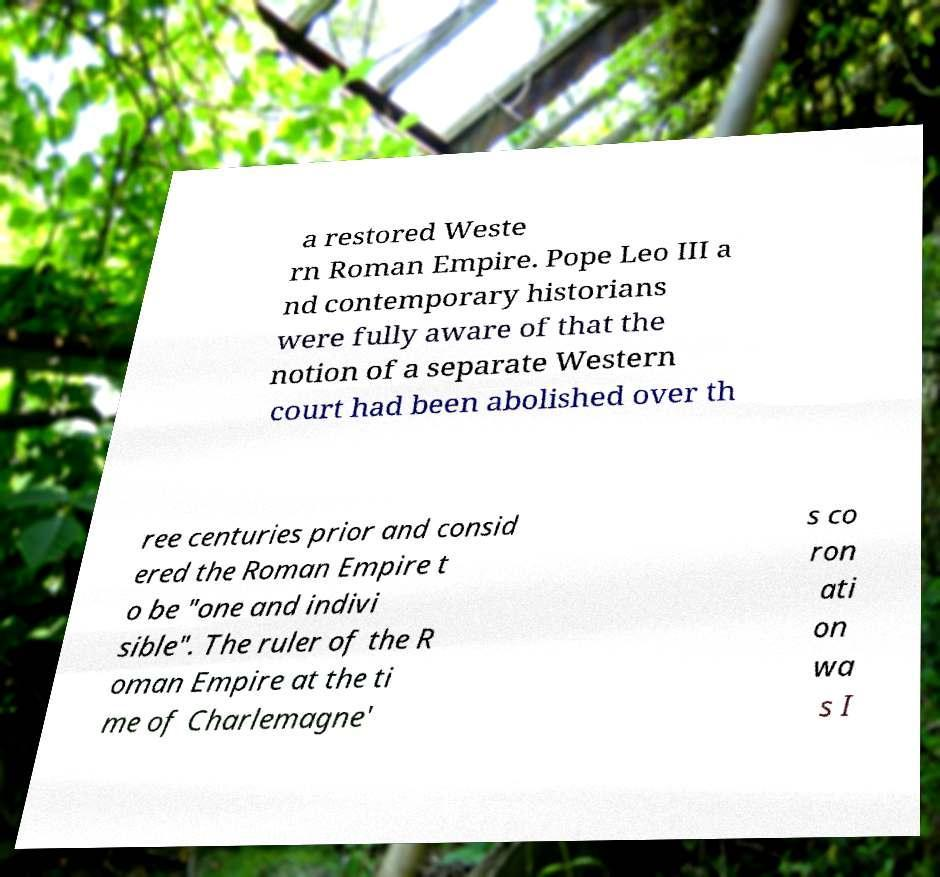Please identify and transcribe the text found in this image. a restored Weste rn Roman Empire. Pope Leo III a nd contemporary historians were fully aware of that the notion of a separate Western court had been abolished over th ree centuries prior and consid ered the Roman Empire t o be "one and indivi sible". The ruler of the R oman Empire at the ti me of Charlemagne' s co ron ati on wa s I 